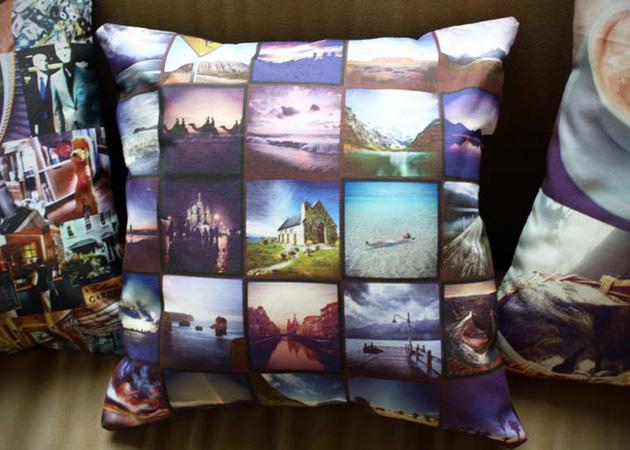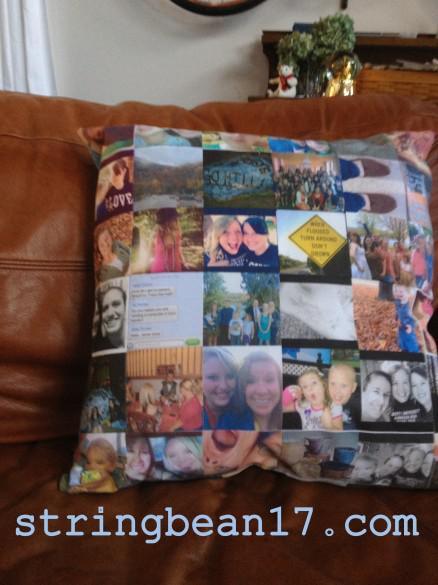The first image is the image on the left, the second image is the image on the right. Considering the images on both sides, is "At least one of the pillows is designed to look like the Instagram logo." valid? Answer yes or no. No. The first image is the image on the left, the second image is the image on the right. For the images shown, is this caption "Each image includes a square pillow containing multiple rows of pictures, and in at least one image, the pictures on the pillow form a collage with no space between them." true? Answer yes or no. Yes. 